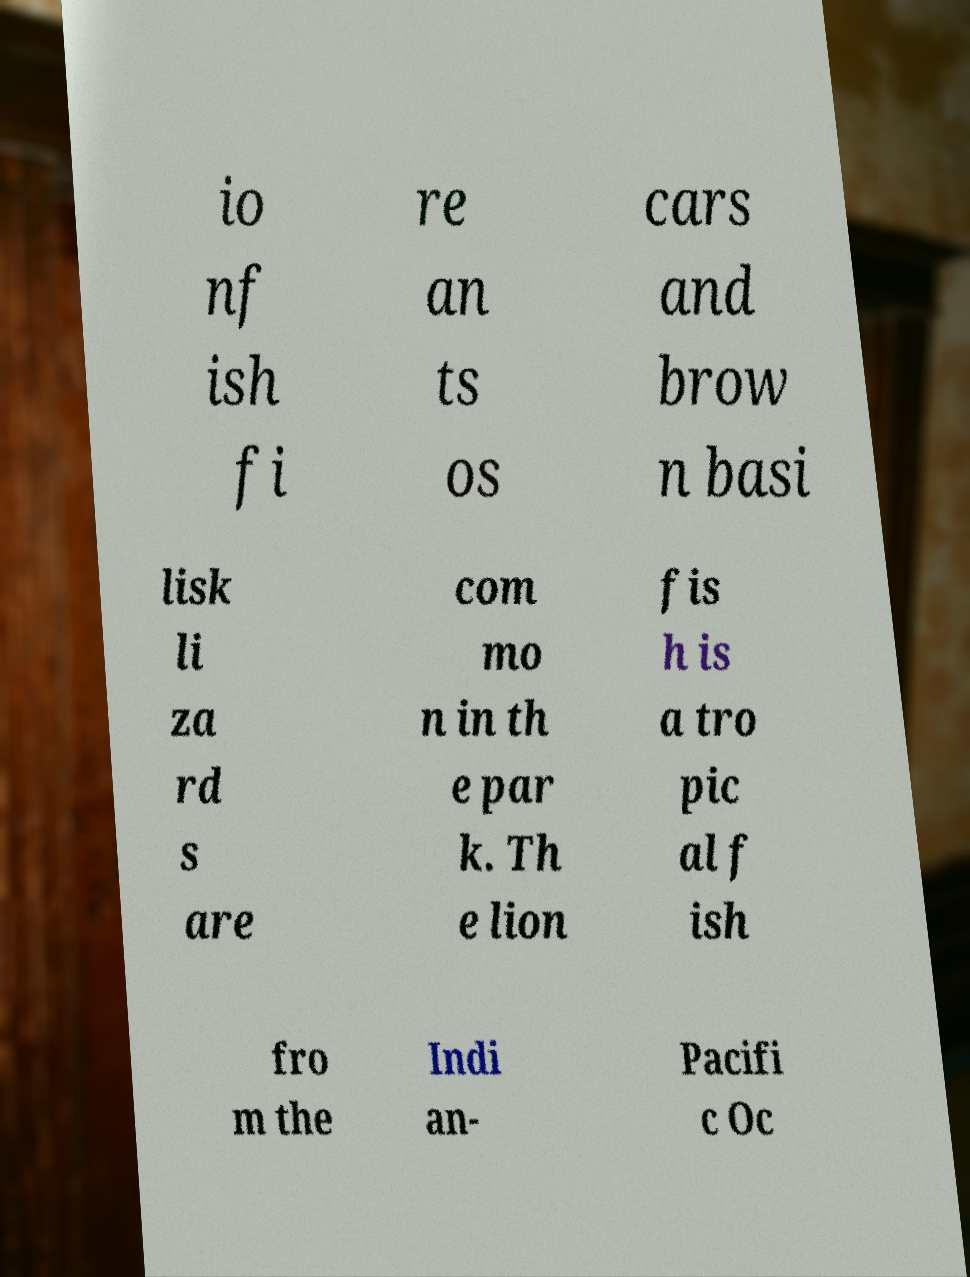Please read and relay the text visible in this image. What does it say? io nf ish fi re an ts os cars and brow n basi lisk li za rd s are com mo n in th e par k. Th e lion fis h is a tro pic al f ish fro m the Indi an- Pacifi c Oc 